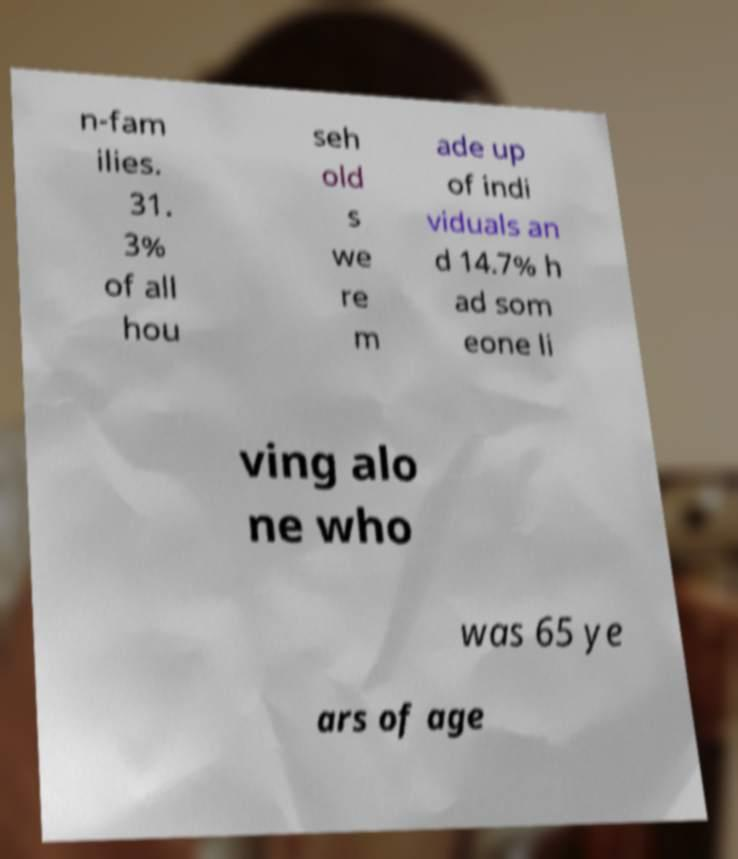Could you extract and type out the text from this image? n-fam ilies. 31. 3% of all hou seh old s we re m ade up of indi viduals an d 14.7% h ad som eone li ving alo ne who was 65 ye ars of age 